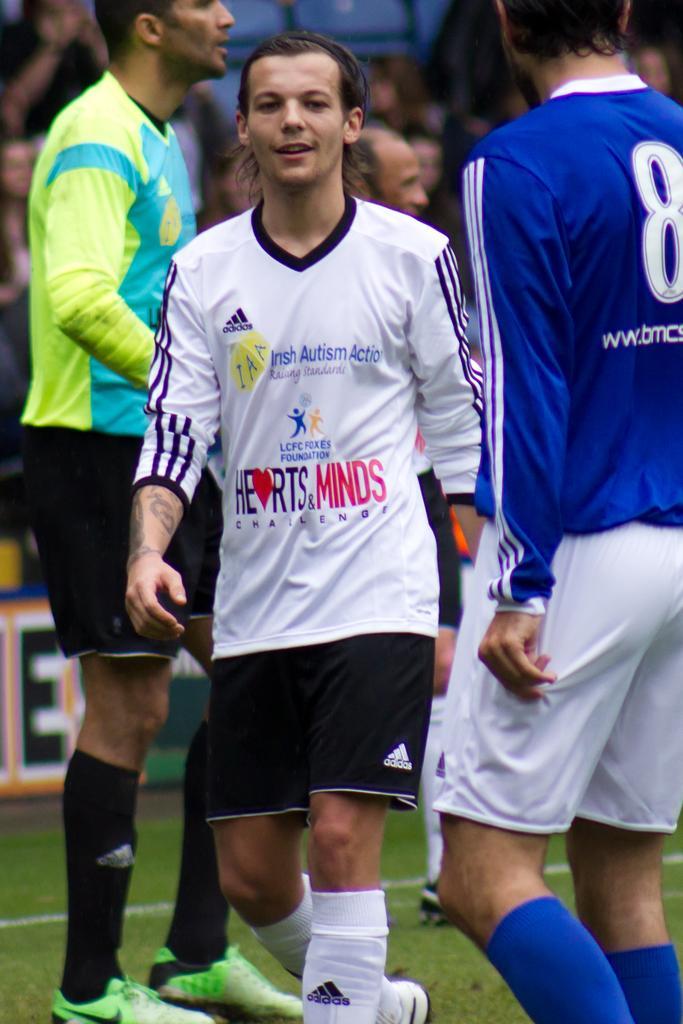Could you give a brief overview of what you see in this image? In this image I can see three persons standing. And in the background there are group of people. 